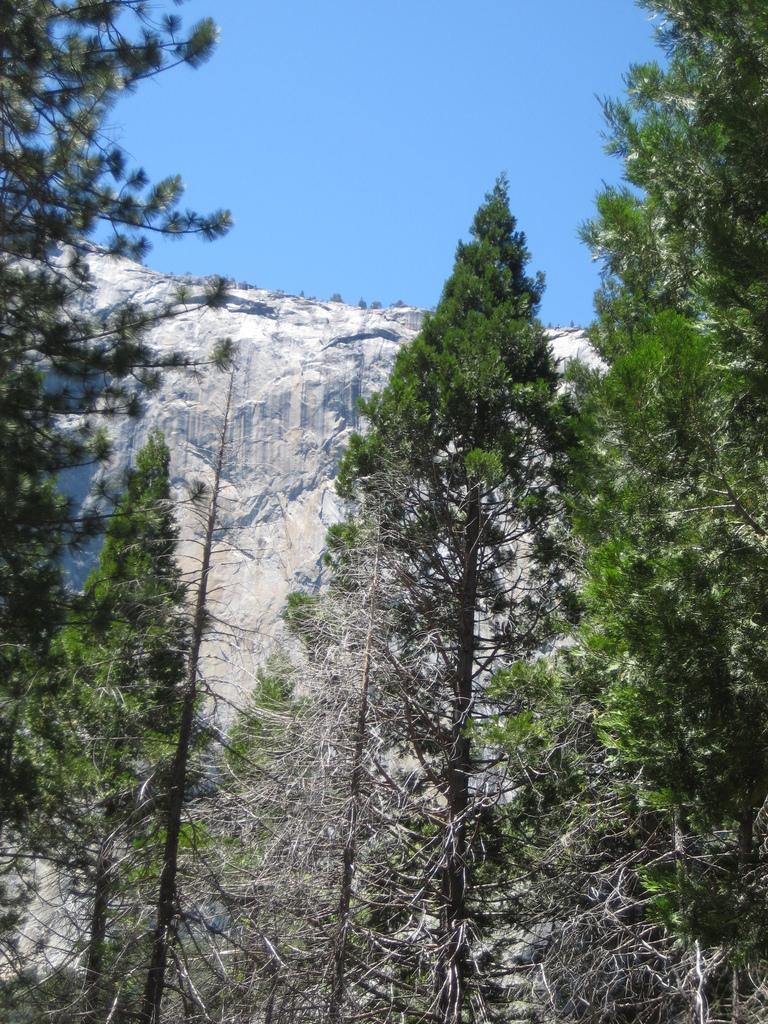Can you describe this image briefly? Here, we can see some green trees, there is a mountain and at the top there is a blue color sky. 